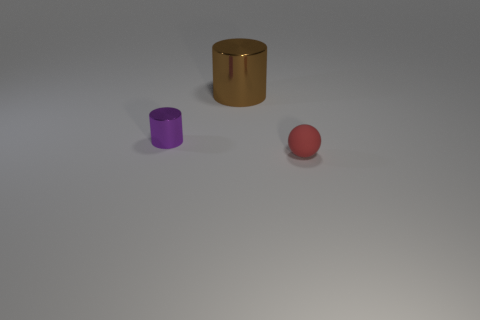Is there anything else that is made of the same material as the red thing?
Offer a terse response. No. Are there any brown metal objects that have the same size as the matte object?
Your answer should be compact. No. Are the large thing and the small purple cylinder made of the same material?
Your answer should be compact. Yes. How many objects are tiny purple shiny things or cylinders?
Give a very brief answer. 2. What size is the matte thing?
Provide a short and direct response. Small. Are there fewer green objects than small red balls?
Ensure brevity in your answer.  Yes. What number of other small spheres are the same color as the matte sphere?
Your response must be concise. 0. The thing that is on the left side of the large brown thing has what shape?
Provide a succinct answer. Cylinder. There is a small thing that is to the left of the big metallic object; is there a small red matte ball behind it?
Make the answer very short. No. How many big brown cylinders are the same material as the small ball?
Provide a short and direct response. 0. 